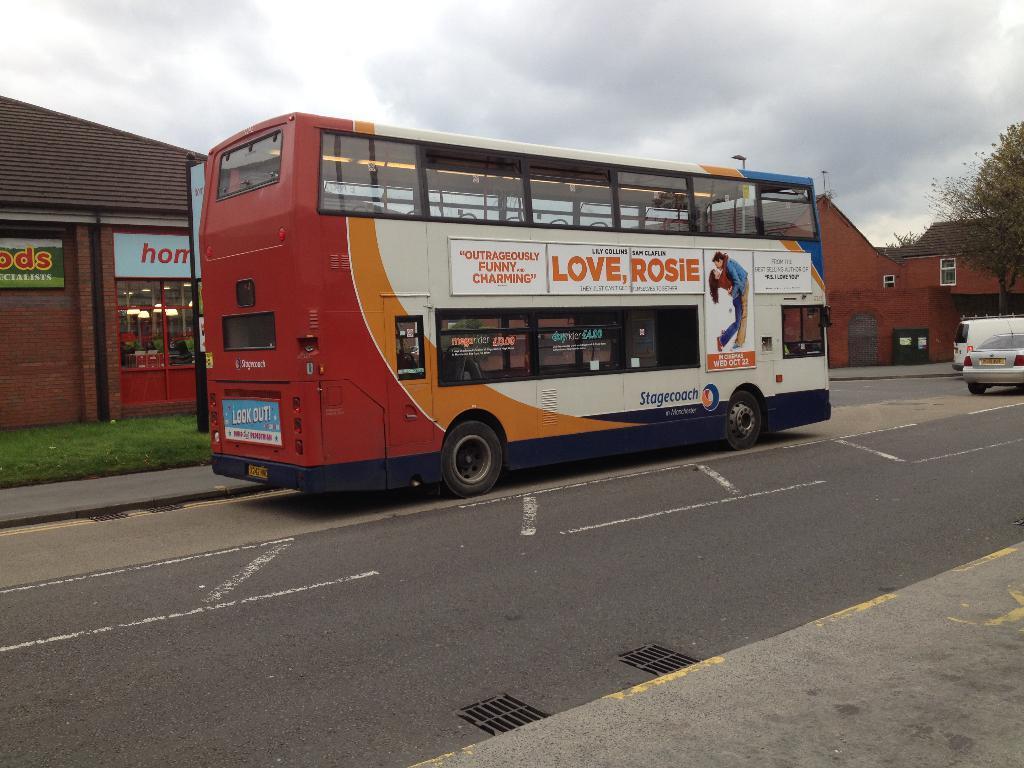How would you summarize this image in a sentence or two? In this image a bus is moving on the road. In the right few other vehicles are moving. In the background there are buildings, trees. The sky is cloudy. 